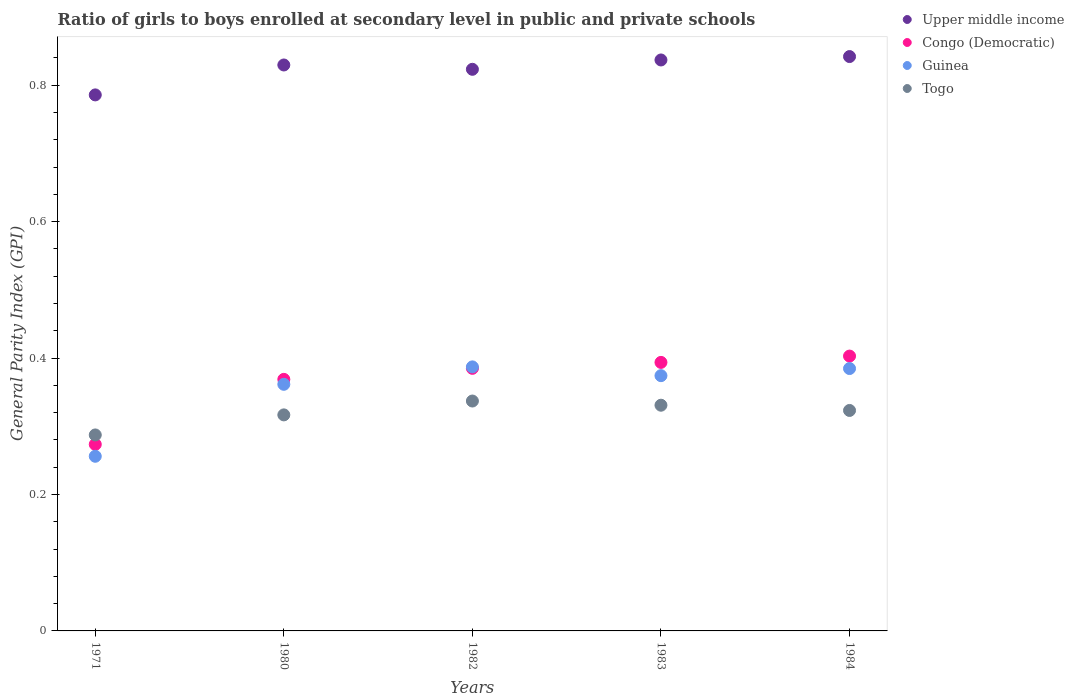How many different coloured dotlines are there?
Make the answer very short. 4. Is the number of dotlines equal to the number of legend labels?
Your answer should be compact. Yes. What is the general parity index in Upper middle income in 1983?
Keep it short and to the point. 0.84. Across all years, what is the maximum general parity index in Congo (Democratic)?
Provide a short and direct response. 0.4. Across all years, what is the minimum general parity index in Guinea?
Offer a terse response. 0.26. In which year was the general parity index in Congo (Democratic) maximum?
Your response must be concise. 1984. What is the total general parity index in Guinea in the graph?
Your answer should be very brief. 1.76. What is the difference between the general parity index in Congo (Democratic) in 1982 and that in 1983?
Provide a succinct answer. -0.01. What is the difference between the general parity index in Guinea in 1971 and the general parity index in Upper middle income in 1982?
Your answer should be very brief. -0.57. What is the average general parity index in Upper middle income per year?
Provide a succinct answer. 0.82. In the year 1971, what is the difference between the general parity index in Guinea and general parity index in Upper middle income?
Your response must be concise. -0.53. In how many years, is the general parity index in Guinea greater than 0.12?
Provide a short and direct response. 5. What is the ratio of the general parity index in Guinea in 1982 to that in 1983?
Offer a very short reply. 1.03. Is the general parity index in Guinea in 1982 less than that in 1984?
Give a very brief answer. No. What is the difference between the highest and the second highest general parity index in Upper middle income?
Give a very brief answer. 0. What is the difference between the highest and the lowest general parity index in Congo (Democratic)?
Give a very brief answer. 0.13. Is the sum of the general parity index in Upper middle income in 1983 and 1984 greater than the maximum general parity index in Congo (Democratic) across all years?
Give a very brief answer. Yes. Is it the case that in every year, the sum of the general parity index in Guinea and general parity index in Togo  is greater than the sum of general parity index in Congo (Democratic) and general parity index in Upper middle income?
Provide a short and direct response. No. Does the general parity index in Togo monotonically increase over the years?
Your response must be concise. No. Is the general parity index in Guinea strictly greater than the general parity index in Togo over the years?
Your response must be concise. No. Is the general parity index in Togo strictly less than the general parity index in Upper middle income over the years?
Give a very brief answer. Yes. How many dotlines are there?
Offer a terse response. 4. Does the graph contain grids?
Your response must be concise. No. Where does the legend appear in the graph?
Give a very brief answer. Top right. How are the legend labels stacked?
Provide a succinct answer. Vertical. What is the title of the graph?
Ensure brevity in your answer.  Ratio of girls to boys enrolled at secondary level in public and private schools. Does "Low income" appear as one of the legend labels in the graph?
Your answer should be very brief. No. What is the label or title of the X-axis?
Make the answer very short. Years. What is the label or title of the Y-axis?
Ensure brevity in your answer.  General Parity Index (GPI). What is the General Parity Index (GPI) in Upper middle income in 1971?
Ensure brevity in your answer.  0.79. What is the General Parity Index (GPI) of Congo (Democratic) in 1971?
Provide a succinct answer. 0.27. What is the General Parity Index (GPI) in Guinea in 1971?
Make the answer very short. 0.26. What is the General Parity Index (GPI) in Togo in 1971?
Make the answer very short. 0.29. What is the General Parity Index (GPI) of Upper middle income in 1980?
Your response must be concise. 0.83. What is the General Parity Index (GPI) in Congo (Democratic) in 1980?
Your answer should be compact. 0.37. What is the General Parity Index (GPI) in Guinea in 1980?
Your response must be concise. 0.36. What is the General Parity Index (GPI) in Togo in 1980?
Your answer should be very brief. 0.32. What is the General Parity Index (GPI) of Upper middle income in 1982?
Give a very brief answer. 0.82. What is the General Parity Index (GPI) in Congo (Democratic) in 1982?
Your response must be concise. 0.38. What is the General Parity Index (GPI) of Guinea in 1982?
Your answer should be very brief. 0.39. What is the General Parity Index (GPI) in Togo in 1982?
Offer a very short reply. 0.34. What is the General Parity Index (GPI) of Upper middle income in 1983?
Make the answer very short. 0.84. What is the General Parity Index (GPI) in Congo (Democratic) in 1983?
Keep it short and to the point. 0.39. What is the General Parity Index (GPI) of Guinea in 1983?
Offer a very short reply. 0.37. What is the General Parity Index (GPI) in Togo in 1983?
Keep it short and to the point. 0.33. What is the General Parity Index (GPI) in Upper middle income in 1984?
Give a very brief answer. 0.84. What is the General Parity Index (GPI) in Congo (Democratic) in 1984?
Provide a succinct answer. 0.4. What is the General Parity Index (GPI) of Guinea in 1984?
Offer a very short reply. 0.38. What is the General Parity Index (GPI) in Togo in 1984?
Provide a short and direct response. 0.32. Across all years, what is the maximum General Parity Index (GPI) in Upper middle income?
Offer a terse response. 0.84. Across all years, what is the maximum General Parity Index (GPI) in Congo (Democratic)?
Make the answer very short. 0.4. Across all years, what is the maximum General Parity Index (GPI) in Guinea?
Your answer should be very brief. 0.39. Across all years, what is the maximum General Parity Index (GPI) in Togo?
Make the answer very short. 0.34. Across all years, what is the minimum General Parity Index (GPI) in Upper middle income?
Make the answer very short. 0.79. Across all years, what is the minimum General Parity Index (GPI) in Congo (Democratic)?
Give a very brief answer. 0.27. Across all years, what is the minimum General Parity Index (GPI) in Guinea?
Your answer should be very brief. 0.26. Across all years, what is the minimum General Parity Index (GPI) of Togo?
Your answer should be very brief. 0.29. What is the total General Parity Index (GPI) in Upper middle income in the graph?
Keep it short and to the point. 4.12. What is the total General Parity Index (GPI) in Congo (Democratic) in the graph?
Your response must be concise. 1.82. What is the total General Parity Index (GPI) of Guinea in the graph?
Offer a very short reply. 1.76. What is the total General Parity Index (GPI) in Togo in the graph?
Offer a very short reply. 1.59. What is the difference between the General Parity Index (GPI) of Upper middle income in 1971 and that in 1980?
Ensure brevity in your answer.  -0.04. What is the difference between the General Parity Index (GPI) of Congo (Democratic) in 1971 and that in 1980?
Make the answer very short. -0.1. What is the difference between the General Parity Index (GPI) in Guinea in 1971 and that in 1980?
Keep it short and to the point. -0.11. What is the difference between the General Parity Index (GPI) in Togo in 1971 and that in 1980?
Offer a very short reply. -0.03. What is the difference between the General Parity Index (GPI) of Upper middle income in 1971 and that in 1982?
Make the answer very short. -0.04. What is the difference between the General Parity Index (GPI) in Congo (Democratic) in 1971 and that in 1982?
Your answer should be compact. -0.11. What is the difference between the General Parity Index (GPI) of Guinea in 1971 and that in 1982?
Keep it short and to the point. -0.13. What is the difference between the General Parity Index (GPI) of Togo in 1971 and that in 1982?
Your response must be concise. -0.05. What is the difference between the General Parity Index (GPI) in Upper middle income in 1971 and that in 1983?
Give a very brief answer. -0.05. What is the difference between the General Parity Index (GPI) in Congo (Democratic) in 1971 and that in 1983?
Give a very brief answer. -0.12. What is the difference between the General Parity Index (GPI) in Guinea in 1971 and that in 1983?
Your answer should be very brief. -0.12. What is the difference between the General Parity Index (GPI) of Togo in 1971 and that in 1983?
Your response must be concise. -0.04. What is the difference between the General Parity Index (GPI) in Upper middle income in 1971 and that in 1984?
Your answer should be very brief. -0.06. What is the difference between the General Parity Index (GPI) of Congo (Democratic) in 1971 and that in 1984?
Ensure brevity in your answer.  -0.13. What is the difference between the General Parity Index (GPI) in Guinea in 1971 and that in 1984?
Your answer should be very brief. -0.13. What is the difference between the General Parity Index (GPI) of Togo in 1971 and that in 1984?
Keep it short and to the point. -0.04. What is the difference between the General Parity Index (GPI) in Upper middle income in 1980 and that in 1982?
Provide a short and direct response. 0.01. What is the difference between the General Parity Index (GPI) of Congo (Democratic) in 1980 and that in 1982?
Offer a very short reply. -0.02. What is the difference between the General Parity Index (GPI) of Guinea in 1980 and that in 1982?
Offer a terse response. -0.03. What is the difference between the General Parity Index (GPI) in Togo in 1980 and that in 1982?
Give a very brief answer. -0.02. What is the difference between the General Parity Index (GPI) of Upper middle income in 1980 and that in 1983?
Ensure brevity in your answer.  -0.01. What is the difference between the General Parity Index (GPI) of Congo (Democratic) in 1980 and that in 1983?
Ensure brevity in your answer.  -0.02. What is the difference between the General Parity Index (GPI) in Guinea in 1980 and that in 1983?
Keep it short and to the point. -0.01. What is the difference between the General Parity Index (GPI) of Togo in 1980 and that in 1983?
Make the answer very short. -0.01. What is the difference between the General Parity Index (GPI) of Upper middle income in 1980 and that in 1984?
Provide a succinct answer. -0.01. What is the difference between the General Parity Index (GPI) of Congo (Democratic) in 1980 and that in 1984?
Your answer should be compact. -0.03. What is the difference between the General Parity Index (GPI) in Guinea in 1980 and that in 1984?
Offer a very short reply. -0.02. What is the difference between the General Parity Index (GPI) in Togo in 1980 and that in 1984?
Make the answer very short. -0.01. What is the difference between the General Parity Index (GPI) in Upper middle income in 1982 and that in 1983?
Keep it short and to the point. -0.01. What is the difference between the General Parity Index (GPI) of Congo (Democratic) in 1982 and that in 1983?
Offer a terse response. -0.01. What is the difference between the General Parity Index (GPI) in Guinea in 1982 and that in 1983?
Your answer should be compact. 0.01. What is the difference between the General Parity Index (GPI) of Togo in 1982 and that in 1983?
Your answer should be compact. 0.01. What is the difference between the General Parity Index (GPI) in Upper middle income in 1982 and that in 1984?
Give a very brief answer. -0.02. What is the difference between the General Parity Index (GPI) of Congo (Democratic) in 1982 and that in 1984?
Give a very brief answer. -0.02. What is the difference between the General Parity Index (GPI) of Guinea in 1982 and that in 1984?
Your answer should be compact. 0. What is the difference between the General Parity Index (GPI) of Togo in 1982 and that in 1984?
Offer a terse response. 0.01. What is the difference between the General Parity Index (GPI) in Upper middle income in 1983 and that in 1984?
Provide a succinct answer. -0.01. What is the difference between the General Parity Index (GPI) in Congo (Democratic) in 1983 and that in 1984?
Ensure brevity in your answer.  -0.01. What is the difference between the General Parity Index (GPI) in Guinea in 1983 and that in 1984?
Offer a terse response. -0.01. What is the difference between the General Parity Index (GPI) in Togo in 1983 and that in 1984?
Offer a terse response. 0.01. What is the difference between the General Parity Index (GPI) in Upper middle income in 1971 and the General Parity Index (GPI) in Congo (Democratic) in 1980?
Offer a terse response. 0.42. What is the difference between the General Parity Index (GPI) of Upper middle income in 1971 and the General Parity Index (GPI) of Guinea in 1980?
Provide a short and direct response. 0.42. What is the difference between the General Parity Index (GPI) of Upper middle income in 1971 and the General Parity Index (GPI) of Togo in 1980?
Keep it short and to the point. 0.47. What is the difference between the General Parity Index (GPI) in Congo (Democratic) in 1971 and the General Parity Index (GPI) in Guinea in 1980?
Your answer should be compact. -0.09. What is the difference between the General Parity Index (GPI) of Congo (Democratic) in 1971 and the General Parity Index (GPI) of Togo in 1980?
Your answer should be compact. -0.04. What is the difference between the General Parity Index (GPI) in Guinea in 1971 and the General Parity Index (GPI) in Togo in 1980?
Give a very brief answer. -0.06. What is the difference between the General Parity Index (GPI) of Upper middle income in 1971 and the General Parity Index (GPI) of Congo (Democratic) in 1982?
Provide a short and direct response. 0.4. What is the difference between the General Parity Index (GPI) of Upper middle income in 1971 and the General Parity Index (GPI) of Guinea in 1982?
Provide a short and direct response. 0.4. What is the difference between the General Parity Index (GPI) in Upper middle income in 1971 and the General Parity Index (GPI) in Togo in 1982?
Give a very brief answer. 0.45. What is the difference between the General Parity Index (GPI) of Congo (Democratic) in 1971 and the General Parity Index (GPI) of Guinea in 1982?
Provide a short and direct response. -0.11. What is the difference between the General Parity Index (GPI) of Congo (Democratic) in 1971 and the General Parity Index (GPI) of Togo in 1982?
Keep it short and to the point. -0.06. What is the difference between the General Parity Index (GPI) of Guinea in 1971 and the General Parity Index (GPI) of Togo in 1982?
Your response must be concise. -0.08. What is the difference between the General Parity Index (GPI) of Upper middle income in 1971 and the General Parity Index (GPI) of Congo (Democratic) in 1983?
Make the answer very short. 0.39. What is the difference between the General Parity Index (GPI) of Upper middle income in 1971 and the General Parity Index (GPI) of Guinea in 1983?
Make the answer very short. 0.41. What is the difference between the General Parity Index (GPI) in Upper middle income in 1971 and the General Parity Index (GPI) in Togo in 1983?
Make the answer very short. 0.45. What is the difference between the General Parity Index (GPI) of Congo (Democratic) in 1971 and the General Parity Index (GPI) of Guinea in 1983?
Offer a very short reply. -0.1. What is the difference between the General Parity Index (GPI) in Congo (Democratic) in 1971 and the General Parity Index (GPI) in Togo in 1983?
Keep it short and to the point. -0.06. What is the difference between the General Parity Index (GPI) of Guinea in 1971 and the General Parity Index (GPI) of Togo in 1983?
Your response must be concise. -0.07. What is the difference between the General Parity Index (GPI) in Upper middle income in 1971 and the General Parity Index (GPI) in Congo (Democratic) in 1984?
Provide a short and direct response. 0.38. What is the difference between the General Parity Index (GPI) of Upper middle income in 1971 and the General Parity Index (GPI) of Guinea in 1984?
Keep it short and to the point. 0.4. What is the difference between the General Parity Index (GPI) of Upper middle income in 1971 and the General Parity Index (GPI) of Togo in 1984?
Your response must be concise. 0.46. What is the difference between the General Parity Index (GPI) of Congo (Democratic) in 1971 and the General Parity Index (GPI) of Guinea in 1984?
Provide a succinct answer. -0.11. What is the difference between the General Parity Index (GPI) in Congo (Democratic) in 1971 and the General Parity Index (GPI) in Togo in 1984?
Your response must be concise. -0.05. What is the difference between the General Parity Index (GPI) in Guinea in 1971 and the General Parity Index (GPI) in Togo in 1984?
Keep it short and to the point. -0.07. What is the difference between the General Parity Index (GPI) in Upper middle income in 1980 and the General Parity Index (GPI) in Congo (Democratic) in 1982?
Give a very brief answer. 0.44. What is the difference between the General Parity Index (GPI) in Upper middle income in 1980 and the General Parity Index (GPI) in Guinea in 1982?
Your response must be concise. 0.44. What is the difference between the General Parity Index (GPI) of Upper middle income in 1980 and the General Parity Index (GPI) of Togo in 1982?
Give a very brief answer. 0.49. What is the difference between the General Parity Index (GPI) of Congo (Democratic) in 1980 and the General Parity Index (GPI) of Guinea in 1982?
Keep it short and to the point. -0.02. What is the difference between the General Parity Index (GPI) of Congo (Democratic) in 1980 and the General Parity Index (GPI) of Togo in 1982?
Your answer should be very brief. 0.03. What is the difference between the General Parity Index (GPI) of Guinea in 1980 and the General Parity Index (GPI) of Togo in 1982?
Give a very brief answer. 0.02. What is the difference between the General Parity Index (GPI) of Upper middle income in 1980 and the General Parity Index (GPI) of Congo (Democratic) in 1983?
Offer a very short reply. 0.44. What is the difference between the General Parity Index (GPI) of Upper middle income in 1980 and the General Parity Index (GPI) of Guinea in 1983?
Ensure brevity in your answer.  0.46. What is the difference between the General Parity Index (GPI) of Upper middle income in 1980 and the General Parity Index (GPI) of Togo in 1983?
Your answer should be compact. 0.5. What is the difference between the General Parity Index (GPI) in Congo (Democratic) in 1980 and the General Parity Index (GPI) in Guinea in 1983?
Make the answer very short. -0.01. What is the difference between the General Parity Index (GPI) in Congo (Democratic) in 1980 and the General Parity Index (GPI) in Togo in 1983?
Your response must be concise. 0.04. What is the difference between the General Parity Index (GPI) of Guinea in 1980 and the General Parity Index (GPI) of Togo in 1983?
Your response must be concise. 0.03. What is the difference between the General Parity Index (GPI) in Upper middle income in 1980 and the General Parity Index (GPI) in Congo (Democratic) in 1984?
Give a very brief answer. 0.43. What is the difference between the General Parity Index (GPI) in Upper middle income in 1980 and the General Parity Index (GPI) in Guinea in 1984?
Your response must be concise. 0.45. What is the difference between the General Parity Index (GPI) of Upper middle income in 1980 and the General Parity Index (GPI) of Togo in 1984?
Give a very brief answer. 0.51. What is the difference between the General Parity Index (GPI) of Congo (Democratic) in 1980 and the General Parity Index (GPI) of Guinea in 1984?
Give a very brief answer. -0.02. What is the difference between the General Parity Index (GPI) of Congo (Democratic) in 1980 and the General Parity Index (GPI) of Togo in 1984?
Provide a short and direct response. 0.05. What is the difference between the General Parity Index (GPI) in Guinea in 1980 and the General Parity Index (GPI) in Togo in 1984?
Offer a terse response. 0.04. What is the difference between the General Parity Index (GPI) in Upper middle income in 1982 and the General Parity Index (GPI) in Congo (Democratic) in 1983?
Your answer should be compact. 0.43. What is the difference between the General Parity Index (GPI) of Upper middle income in 1982 and the General Parity Index (GPI) of Guinea in 1983?
Your answer should be very brief. 0.45. What is the difference between the General Parity Index (GPI) of Upper middle income in 1982 and the General Parity Index (GPI) of Togo in 1983?
Keep it short and to the point. 0.49. What is the difference between the General Parity Index (GPI) of Congo (Democratic) in 1982 and the General Parity Index (GPI) of Guinea in 1983?
Keep it short and to the point. 0.01. What is the difference between the General Parity Index (GPI) of Congo (Democratic) in 1982 and the General Parity Index (GPI) of Togo in 1983?
Ensure brevity in your answer.  0.05. What is the difference between the General Parity Index (GPI) in Guinea in 1982 and the General Parity Index (GPI) in Togo in 1983?
Offer a terse response. 0.06. What is the difference between the General Parity Index (GPI) of Upper middle income in 1982 and the General Parity Index (GPI) of Congo (Democratic) in 1984?
Give a very brief answer. 0.42. What is the difference between the General Parity Index (GPI) of Upper middle income in 1982 and the General Parity Index (GPI) of Guinea in 1984?
Your answer should be compact. 0.44. What is the difference between the General Parity Index (GPI) in Upper middle income in 1982 and the General Parity Index (GPI) in Togo in 1984?
Give a very brief answer. 0.5. What is the difference between the General Parity Index (GPI) in Congo (Democratic) in 1982 and the General Parity Index (GPI) in Guinea in 1984?
Keep it short and to the point. 0. What is the difference between the General Parity Index (GPI) in Congo (Democratic) in 1982 and the General Parity Index (GPI) in Togo in 1984?
Your answer should be very brief. 0.06. What is the difference between the General Parity Index (GPI) in Guinea in 1982 and the General Parity Index (GPI) in Togo in 1984?
Your answer should be very brief. 0.06. What is the difference between the General Parity Index (GPI) of Upper middle income in 1983 and the General Parity Index (GPI) of Congo (Democratic) in 1984?
Your answer should be compact. 0.43. What is the difference between the General Parity Index (GPI) of Upper middle income in 1983 and the General Parity Index (GPI) of Guinea in 1984?
Give a very brief answer. 0.45. What is the difference between the General Parity Index (GPI) of Upper middle income in 1983 and the General Parity Index (GPI) of Togo in 1984?
Keep it short and to the point. 0.51. What is the difference between the General Parity Index (GPI) in Congo (Democratic) in 1983 and the General Parity Index (GPI) in Guinea in 1984?
Offer a terse response. 0.01. What is the difference between the General Parity Index (GPI) in Congo (Democratic) in 1983 and the General Parity Index (GPI) in Togo in 1984?
Your response must be concise. 0.07. What is the difference between the General Parity Index (GPI) of Guinea in 1983 and the General Parity Index (GPI) of Togo in 1984?
Make the answer very short. 0.05. What is the average General Parity Index (GPI) in Upper middle income per year?
Provide a succinct answer. 0.82. What is the average General Parity Index (GPI) of Congo (Democratic) per year?
Provide a short and direct response. 0.36. What is the average General Parity Index (GPI) in Guinea per year?
Give a very brief answer. 0.35. What is the average General Parity Index (GPI) of Togo per year?
Ensure brevity in your answer.  0.32. In the year 1971, what is the difference between the General Parity Index (GPI) of Upper middle income and General Parity Index (GPI) of Congo (Democratic)?
Your answer should be very brief. 0.51. In the year 1971, what is the difference between the General Parity Index (GPI) of Upper middle income and General Parity Index (GPI) of Guinea?
Provide a short and direct response. 0.53. In the year 1971, what is the difference between the General Parity Index (GPI) of Upper middle income and General Parity Index (GPI) of Togo?
Give a very brief answer. 0.5. In the year 1971, what is the difference between the General Parity Index (GPI) in Congo (Democratic) and General Parity Index (GPI) in Guinea?
Make the answer very short. 0.02. In the year 1971, what is the difference between the General Parity Index (GPI) of Congo (Democratic) and General Parity Index (GPI) of Togo?
Offer a very short reply. -0.01. In the year 1971, what is the difference between the General Parity Index (GPI) in Guinea and General Parity Index (GPI) in Togo?
Your answer should be compact. -0.03. In the year 1980, what is the difference between the General Parity Index (GPI) in Upper middle income and General Parity Index (GPI) in Congo (Democratic)?
Provide a short and direct response. 0.46. In the year 1980, what is the difference between the General Parity Index (GPI) of Upper middle income and General Parity Index (GPI) of Guinea?
Make the answer very short. 0.47. In the year 1980, what is the difference between the General Parity Index (GPI) of Upper middle income and General Parity Index (GPI) of Togo?
Your response must be concise. 0.51. In the year 1980, what is the difference between the General Parity Index (GPI) of Congo (Democratic) and General Parity Index (GPI) of Guinea?
Provide a succinct answer. 0.01. In the year 1980, what is the difference between the General Parity Index (GPI) in Congo (Democratic) and General Parity Index (GPI) in Togo?
Provide a short and direct response. 0.05. In the year 1980, what is the difference between the General Parity Index (GPI) of Guinea and General Parity Index (GPI) of Togo?
Offer a terse response. 0.04. In the year 1982, what is the difference between the General Parity Index (GPI) of Upper middle income and General Parity Index (GPI) of Congo (Democratic)?
Your answer should be very brief. 0.44. In the year 1982, what is the difference between the General Parity Index (GPI) of Upper middle income and General Parity Index (GPI) of Guinea?
Your answer should be compact. 0.44. In the year 1982, what is the difference between the General Parity Index (GPI) in Upper middle income and General Parity Index (GPI) in Togo?
Give a very brief answer. 0.49. In the year 1982, what is the difference between the General Parity Index (GPI) of Congo (Democratic) and General Parity Index (GPI) of Guinea?
Provide a succinct answer. -0. In the year 1982, what is the difference between the General Parity Index (GPI) in Congo (Democratic) and General Parity Index (GPI) in Togo?
Your answer should be very brief. 0.05. In the year 1982, what is the difference between the General Parity Index (GPI) of Guinea and General Parity Index (GPI) of Togo?
Ensure brevity in your answer.  0.05. In the year 1983, what is the difference between the General Parity Index (GPI) of Upper middle income and General Parity Index (GPI) of Congo (Democratic)?
Provide a succinct answer. 0.44. In the year 1983, what is the difference between the General Parity Index (GPI) of Upper middle income and General Parity Index (GPI) of Guinea?
Provide a succinct answer. 0.46. In the year 1983, what is the difference between the General Parity Index (GPI) of Upper middle income and General Parity Index (GPI) of Togo?
Your answer should be very brief. 0.51. In the year 1983, what is the difference between the General Parity Index (GPI) in Congo (Democratic) and General Parity Index (GPI) in Guinea?
Keep it short and to the point. 0.02. In the year 1983, what is the difference between the General Parity Index (GPI) in Congo (Democratic) and General Parity Index (GPI) in Togo?
Give a very brief answer. 0.06. In the year 1983, what is the difference between the General Parity Index (GPI) of Guinea and General Parity Index (GPI) of Togo?
Offer a very short reply. 0.04. In the year 1984, what is the difference between the General Parity Index (GPI) in Upper middle income and General Parity Index (GPI) in Congo (Democratic)?
Keep it short and to the point. 0.44. In the year 1984, what is the difference between the General Parity Index (GPI) of Upper middle income and General Parity Index (GPI) of Guinea?
Your answer should be very brief. 0.46. In the year 1984, what is the difference between the General Parity Index (GPI) of Upper middle income and General Parity Index (GPI) of Togo?
Provide a short and direct response. 0.52. In the year 1984, what is the difference between the General Parity Index (GPI) of Congo (Democratic) and General Parity Index (GPI) of Guinea?
Your response must be concise. 0.02. In the year 1984, what is the difference between the General Parity Index (GPI) of Congo (Democratic) and General Parity Index (GPI) of Togo?
Your answer should be compact. 0.08. In the year 1984, what is the difference between the General Parity Index (GPI) in Guinea and General Parity Index (GPI) in Togo?
Ensure brevity in your answer.  0.06. What is the ratio of the General Parity Index (GPI) of Upper middle income in 1971 to that in 1980?
Offer a terse response. 0.95. What is the ratio of the General Parity Index (GPI) in Congo (Democratic) in 1971 to that in 1980?
Keep it short and to the point. 0.74. What is the ratio of the General Parity Index (GPI) of Guinea in 1971 to that in 1980?
Provide a succinct answer. 0.71. What is the ratio of the General Parity Index (GPI) in Togo in 1971 to that in 1980?
Your response must be concise. 0.91. What is the ratio of the General Parity Index (GPI) of Upper middle income in 1971 to that in 1982?
Offer a very short reply. 0.95. What is the ratio of the General Parity Index (GPI) in Congo (Democratic) in 1971 to that in 1982?
Keep it short and to the point. 0.71. What is the ratio of the General Parity Index (GPI) of Guinea in 1971 to that in 1982?
Make the answer very short. 0.66. What is the ratio of the General Parity Index (GPI) of Togo in 1971 to that in 1982?
Ensure brevity in your answer.  0.85. What is the ratio of the General Parity Index (GPI) in Upper middle income in 1971 to that in 1983?
Offer a very short reply. 0.94. What is the ratio of the General Parity Index (GPI) in Congo (Democratic) in 1971 to that in 1983?
Make the answer very short. 0.69. What is the ratio of the General Parity Index (GPI) in Guinea in 1971 to that in 1983?
Your response must be concise. 0.68. What is the ratio of the General Parity Index (GPI) of Togo in 1971 to that in 1983?
Keep it short and to the point. 0.87. What is the ratio of the General Parity Index (GPI) in Congo (Democratic) in 1971 to that in 1984?
Provide a short and direct response. 0.68. What is the ratio of the General Parity Index (GPI) of Guinea in 1971 to that in 1984?
Keep it short and to the point. 0.67. What is the ratio of the General Parity Index (GPI) in Togo in 1971 to that in 1984?
Provide a short and direct response. 0.89. What is the ratio of the General Parity Index (GPI) of Upper middle income in 1980 to that in 1982?
Keep it short and to the point. 1.01. What is the ratio of the General Parity Index (GPI) of Congo (Democratic) in 1980 to that in 1982?
Provide a succinct answer. 0.96. What is the ratio of the General Parity Index (GPI) of Guinea in 1980 to that in 1982?
Keep it short and to the point. 0.93. What is the ratio of the General Parity Index (GPI) of Togo in 1980 to that in 1982?
Give a very brief answer. 0.94. What is the ratio of the General Parity Index (GPI) in Congo (Democratic) in 1980 to that in 1983?
Your answer should be very brief. 0.94. What is the ratio of the General Parity Index (GPI) in Guinea in 1980 to that in 1983?
Provide a succinct answer. 0.97. What is the ratio of the General Parity Index (GPI) in Togo in 1980 to that in 1983?
Make the answer very short. 0.96. What is the ratio of the General Parity Index (GPI) in Congo (Democratic) in 1980 to that in 1984?
Offer a very short reply. 0.92. What is the ratio of the General Parity Index (GPI) of Guinea in 1980 to that in 1984?
Offer a terse response. 0.94. What is the ratio of the General Parity Index (GPI) in Togo in 1980 to that in 1984?
Your answer should be compact. 0.98. What is the ratio of the General Parity Index (GPI) in Upper middle income in 1982 to that in 1983?
Provide a succinct answer. 0.98. What is the ratio of the General Parity Index (GPI) of Congo (Democratic) in 1982 to that in 1983?
Ensure brevity in your answer.  0.98. What is the ratio of the General Parity Index (GPI) in Guinea in 1982 to that in 1983?
Give a very brief answer. 1.03. What is the ratio of the General Parity Index (GPI) in Togo in 1982 to that in 1983?
Your answer should be compact. 1.02. What is the ratio of the General Parity Index (GPI) in Upper middle income in 1982 to that in 1984?
Give a very brief answer. 0.98. What is the ratio of the General Parity Index (GPI) in Congo (Democratic) in 1982 to that in 1984?
Your answer should be compact. 0.96. What is the ratio of the General Parity Index (GPI) in Guinea in 1982 to that in 1984?
Your answer should be compact. 1.01. What is the ratio of the General Parity Index (GPI) in Togo in 1982 to that in 1984?
Ensure brevity in your answer.  1.04. What is the ratio of the General Parity Index (GPI) of Upper middle income in 1983 to that in 1984?
Your response must be concise. 0.99. What is the ratio of the General Parity Index (GPI) in Guinea in 1983 to that in 1984?
Make the answer very short. 0.97. What is the ratio of the General Parity Index (GPI) of Togo in 1983 to that in 1984?
Offer a terse response. 1.02. What is the difference between the highest and the second highest General Parity Index (GPI) in Upper middle income?
Ensure brevity in your answer.  0.01. What is the difference between the highest and the second highest General Parity Index (GPI) in Congo (Democratic)?
Give a very brief answer. 0.01. What is the difference between the highest and the second highest General Parity Index (GPI) in Guinea?
Your answer should be compact. 0. What is the difference between the highest and the second highest General Parity Index (GPI) in Togo?
Offer a very short reply. 0.01. What is the difference between the highest and the lowest General Parity Index (GPI) of Upper middle income?
Provide a short and direct response. 0.06. What is the difference between the highest and the lowest General Parity Index (GPI) in Congo (Democratic)?
Provide a short and direct response. 0.13. What is the difference between the highest and the lowest General Parity Index (GPI) in Guinea?
Give a very brief answer. 0.13. What is the difference between the highest and the lowest General Parity Index (GPI) of Togo?
Give a very brief answer. 0.05. 